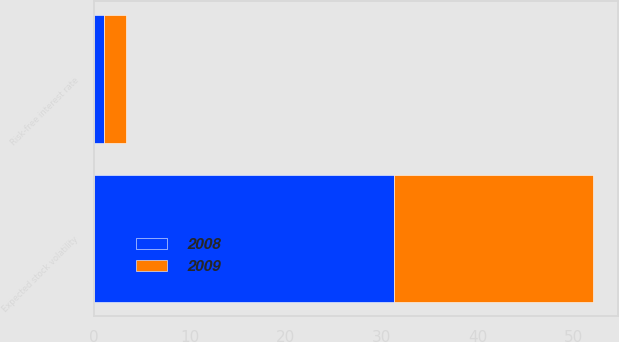Convert chart to OTSL. <chart><loc_0><loc_0><loc_500><loc_500><stacked_bar_chart><ecel><fcel>Risk-free interest rate<fcel>Expected stock volatility<nl><fcel>2008<fcel>1.11<fcel>31.3<nl><fcel>2009<fcel>2.3<fcel>20.7<nl></chart> 